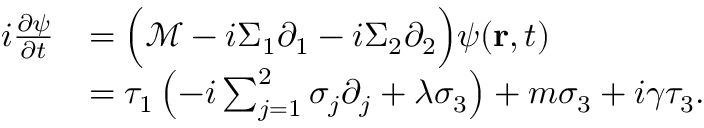Convert formula to latex. <formula><loc_0><loc_0><loc_500><loc_500>\begin{array} { r } { \begin{array} { r l } { i \frac { \partial \psi } { \partial t } } & { = \left ( \mathcal { M } - i \Sigma _ { 1 } \partial _ { 1 } - i \Sigma _ { 2 } \partial _ { 2 } \right ) \psi ( r , t ) } \\ & { = \tau _ { 1 } \left ( - i \sum _ { j = 1 } ^ { 2 } \sigma _ { j } \partial _ { j } + \lambda \sigma _ { 3 } \right ) + m \sigma _ { 3 } + i \gamma \tau _ { 3 } . } \end{array} } \end{array}</formula> 